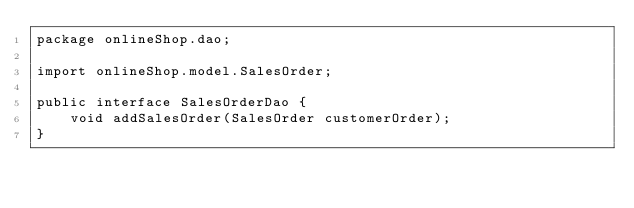Convert code to text. <code><loc_0><loc_0><loc_500><loc_500><_Java_>package onlineShop.dao;

import onlineShop.model.SalesOrder;

public interface SalesOrderDao {
	void addSalesOrder(SalesOrder customerOrder);
}
</code> 